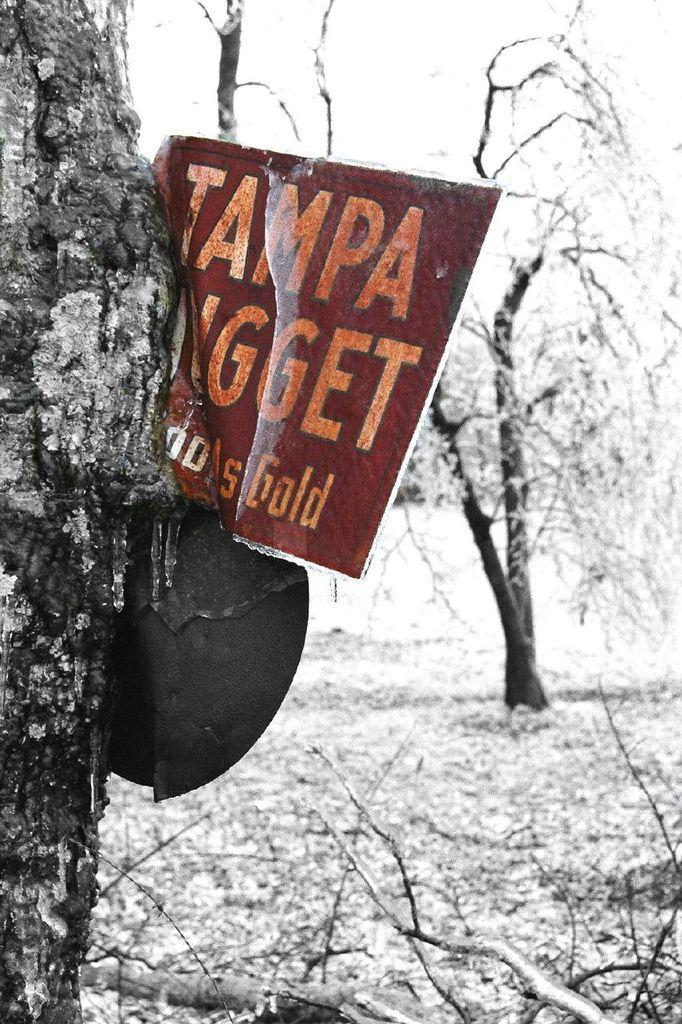How would you summarize this image in a sentence or two? This looks like a board with the letters on it. This is a tree trunk. I can see the trees and branches. 